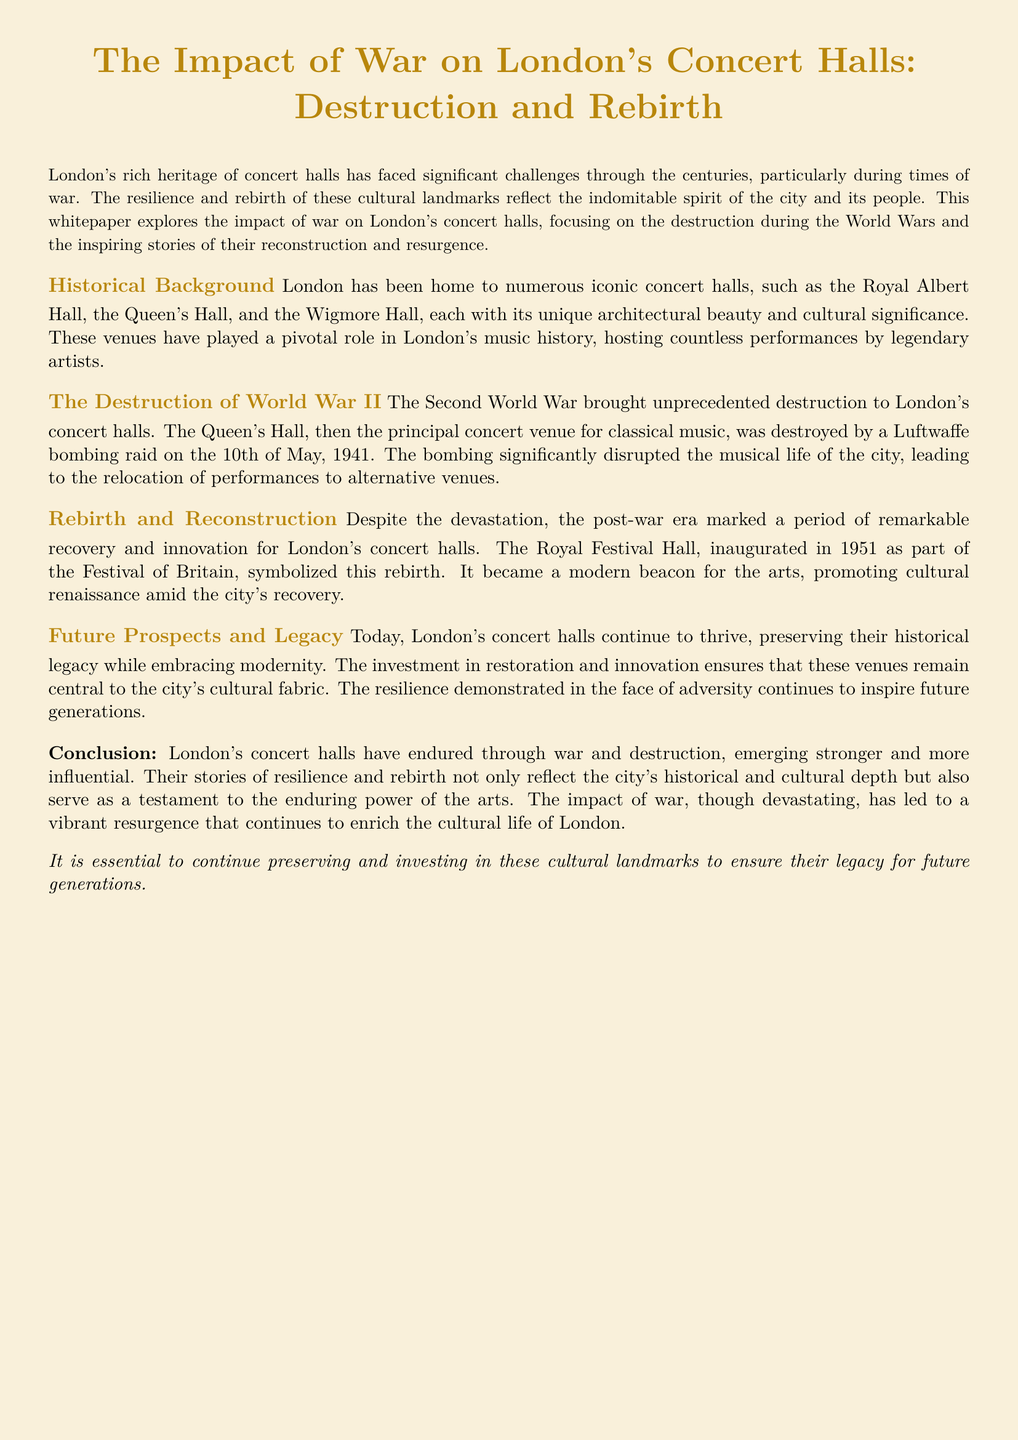What is the title of the whitepaper? The title of the whitepaper is presented at the beginning, encapsulating its main focus.
Answer: The Impact of War on London's Concert Halls: Destruction and Rebirth Which concert hall was destroyed by a bombing raid? The document specifies that the Queen's Hall was destroyed during World War II.
Answer: Queen's Hall When was the Queen's Hall destroyed? The document provides the specific date when the Queen's Hall was destroyed as part of the narrative.
Answer: 10th of May, 1941 What major event inaugurated the Royal Festival Hall? The document mentions a significant cultural event that marked the inauguration of the Royal Festival Hall.
Answer: Festival of Britain What does the whitepaper suggest is essential for the future of concert halls? The conclusion of the document emphasizes an important action needed for the preservation of concert halls.
Answer: Preserving and investing in these cultural landmarks How did World War II affect London's musical life? The document describes the impact of the war on musical performances in the city, indicating a significant change.
Answer: Disruption What symbolizes the rebirth of London’s concert halls? The text indicates a particular concert hall that became a symbol of recovery after the war.
Answer: Royal Festival Hall What aspect of London’s concert halls is emphasized for future generations? The whitepaper mentions a key element regarding the cultural significance of these venues over time.
Answer: Legacy 